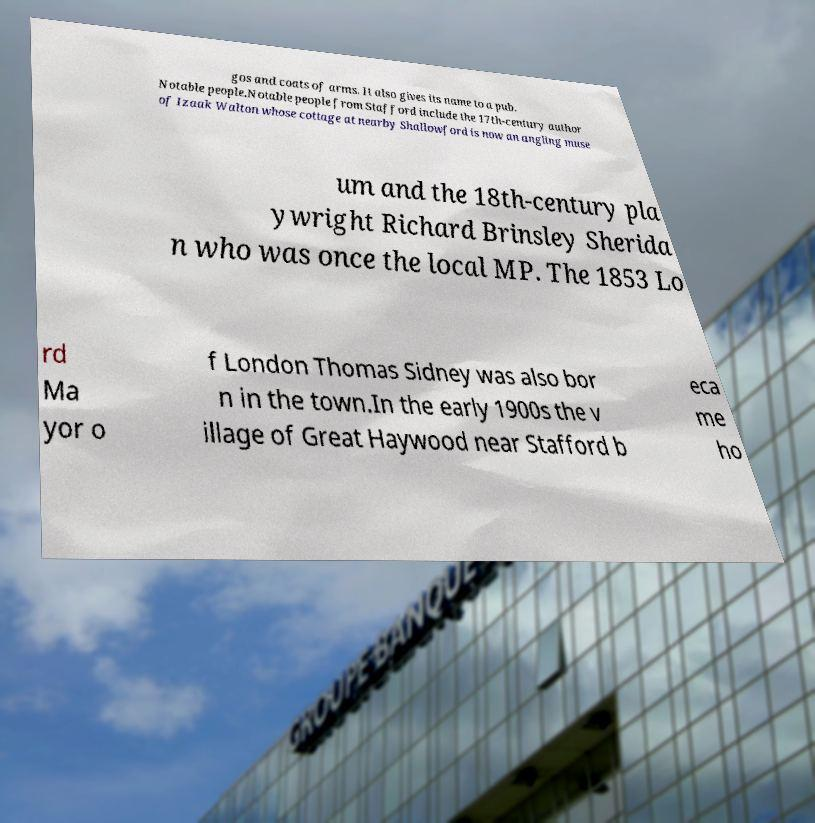Can you read and provide the text displayed in the image?This photo seems to have some interesting text. Can you extract and type it out for me? gos and coats of arms. It also gives its name to a pub. Notable people.Notable people from Stafford include the 17th-century author of Izaak Walton whose cottage at nearby Shallowford is now an angling muse um and the 18th-century pla ywright Richard Brinsley Sherida n who was once the local MP. The 1853 Lo rd Ma yor o f London Thomas Sidney was also bor n in the town.In the early 1900s the v illage of Great Haywood near Stafford b eca me ho 